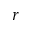Convert formula to latex. <formula><loc_0><loc_0><loc_500><loc_500>r</formula> 